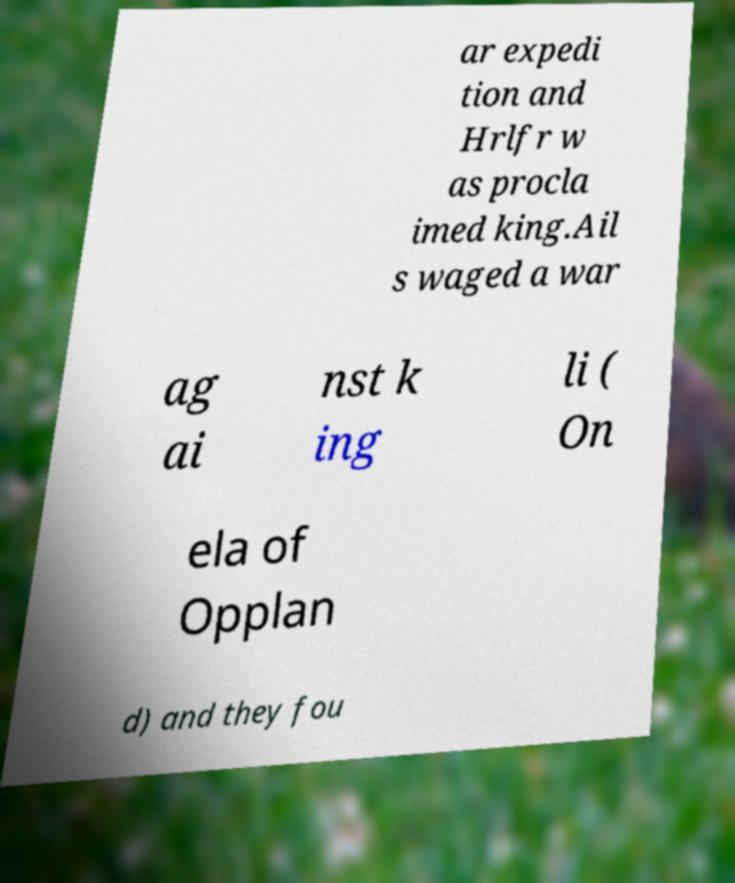What messages or text are displayed in this image? I need them in a readable, typed format. ar expedi tion and Hrlfr w as procla imed king.Ail s waged a war ag ai nst k ing li ( On ela of Opplan d) and they fou 